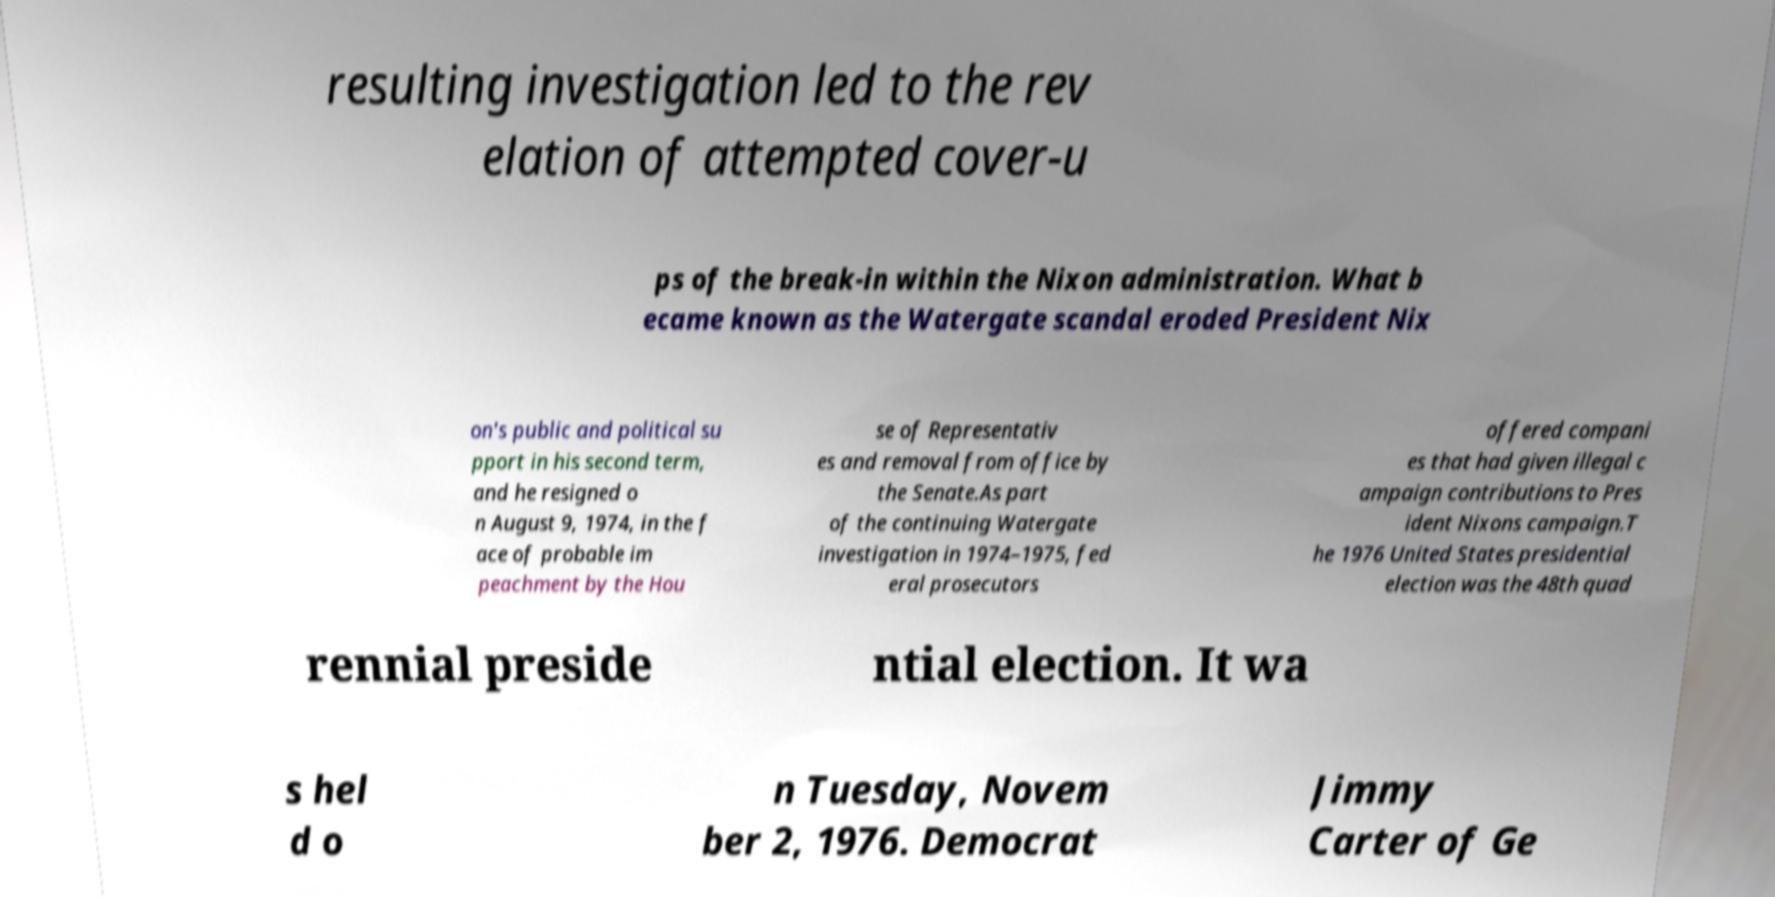Can you accurately transcribe the text from the provided image for me? resulting investigation led to the rev elation of attempted cover-u ps of the break-in within the Nixon administration. What b ecame known as the Watergate scandal eroded President Nix on's public and political su pport in his second term, and he resigned o n August 9, 1974, in the f ace of probable im peachment by the Hou se of Representativ es and removal from office by the Senate.As part of the continuing Watergate investigation in 1974–1975, fed eral prosecutors offered compani es that had given illegal c ampaign contributions to Pres ident Nixons campaign.T he 1976 United States presidential election was the 48th quad rennial preside ntial election. It wa s hel d o n Tuesday, Novem ber 2, 1976. Democrat Jimmy Carter of Ge 